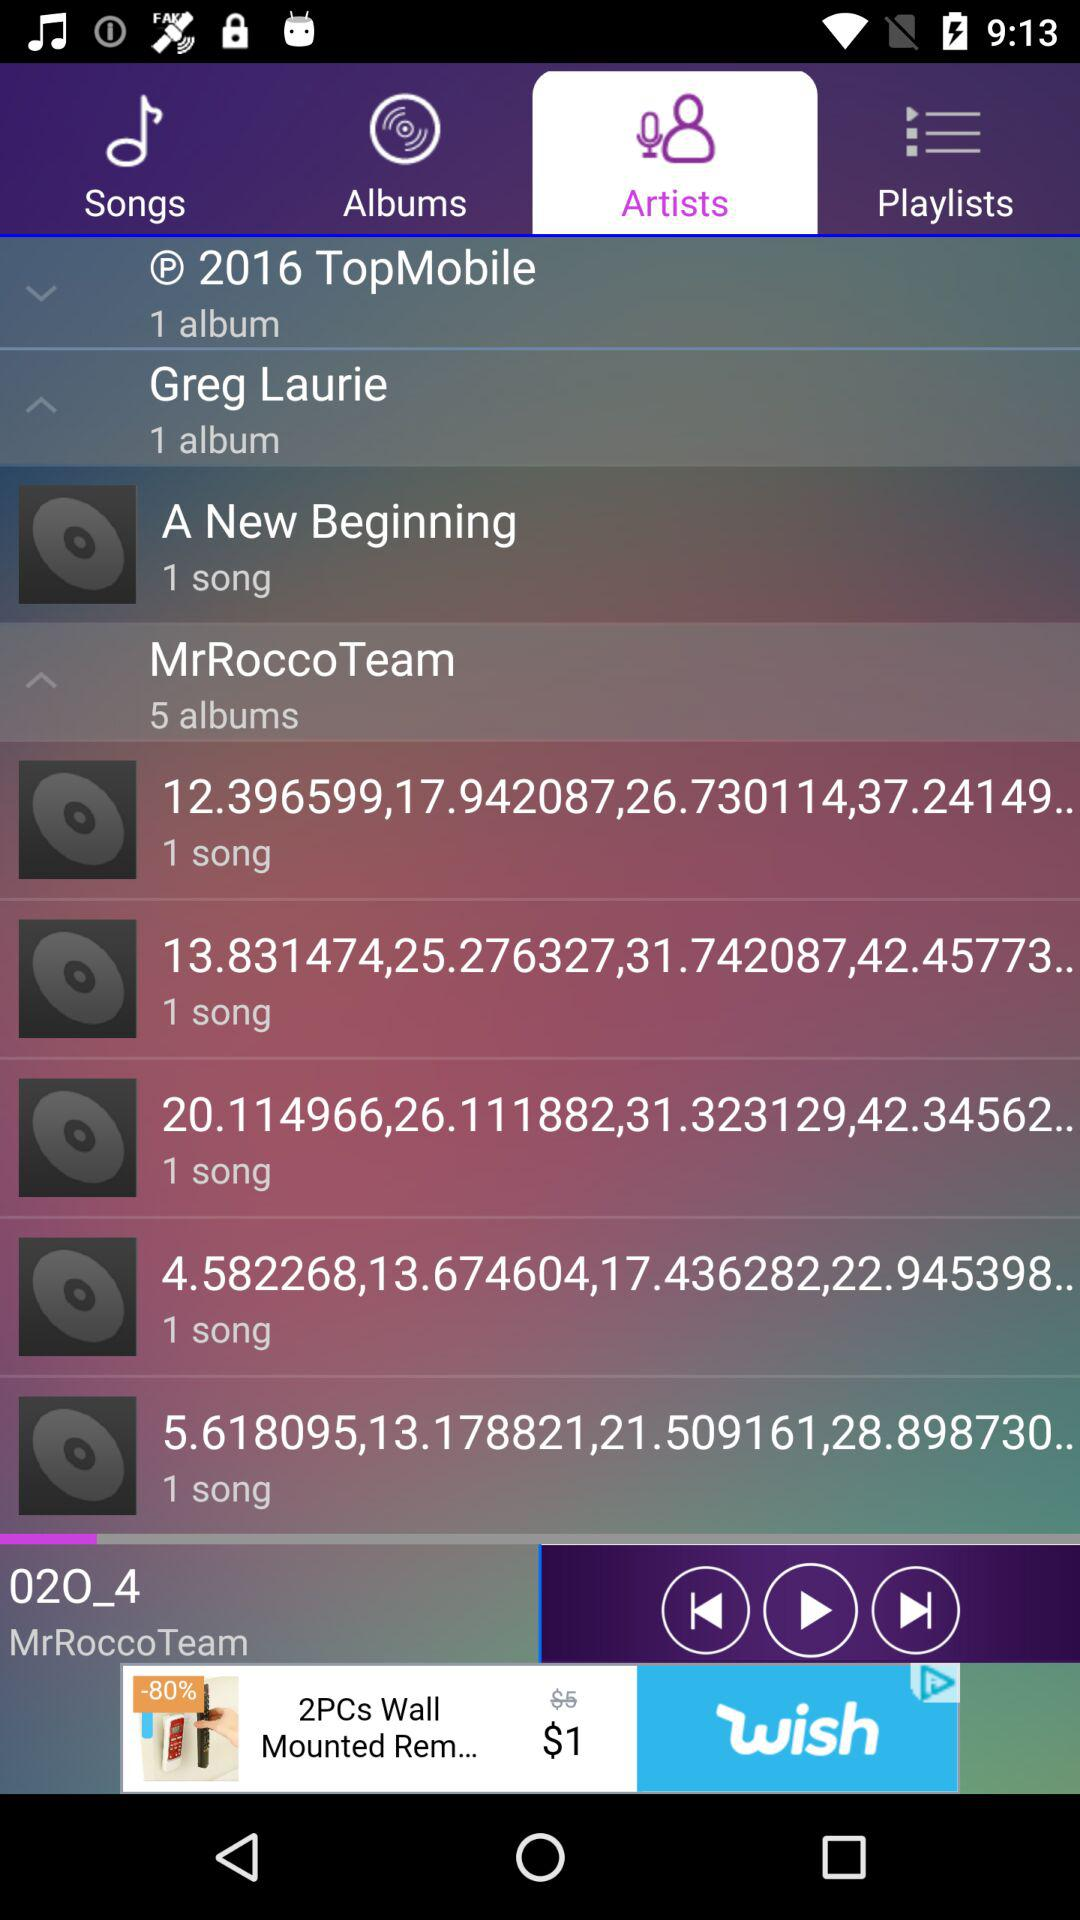How many albums are in "Greg Laurie"? There is one album in "Greg Laurie". 